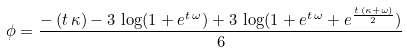<formula> <loc_0><loc_0><loc_500><loc_500>\phi = \frac { - \left ( t \, \kappa \right ) - 3 \, \log ( 1 + e ^ { t \, \omega } ) + 3 \, \log ( 1 + e ^ { t \, \omega } + e ^ { \frac { t \, \left ( \kappa + \omega \right ) } { 2 } } ) } { 6 }</formula> 